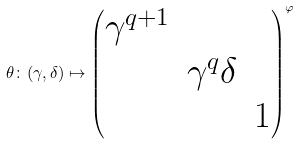<formula> <loc_0><loc_0><loc_500><loc_500>\theta \colon ( \gamma , \delta ) \mapsto \begin{pmatrix} \gamma ^ { q + 1 } & & \\ & \gamma ^ { q } \delta & \\ & & 1 \end{pmatrix} ^ { \varphi }</formula> 